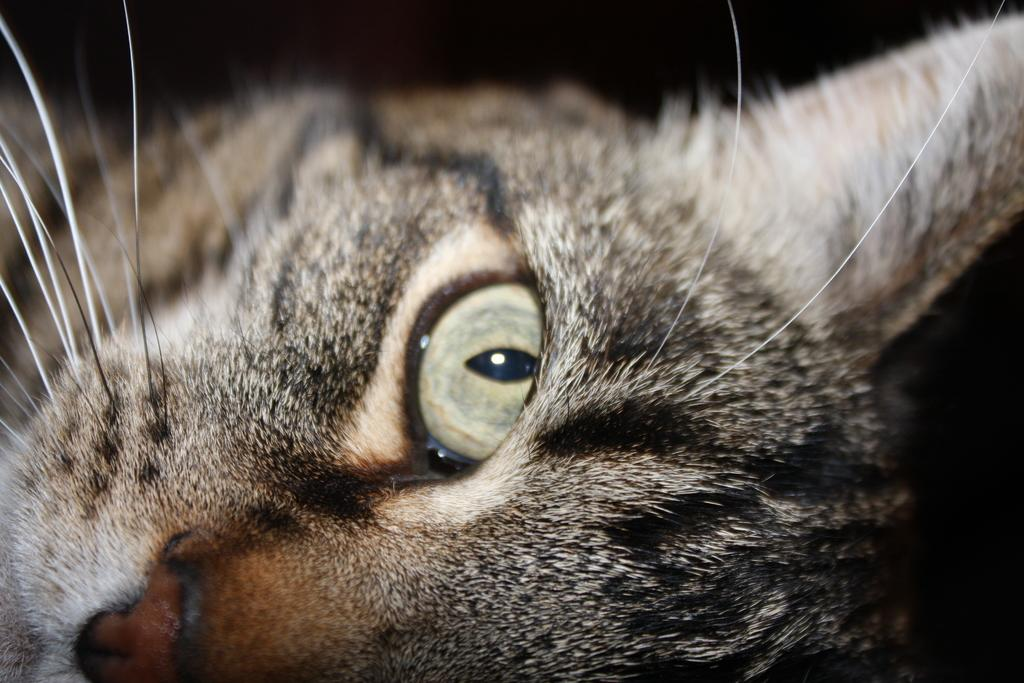What type of animal is in the image? There is a cat in the image. What can be observed about the background of the image? The background of the image is dark. What type of jar is visible in the image? There is no jar present in the image. What tax-related information can be found in the image? There is no tax-related information in the image. 